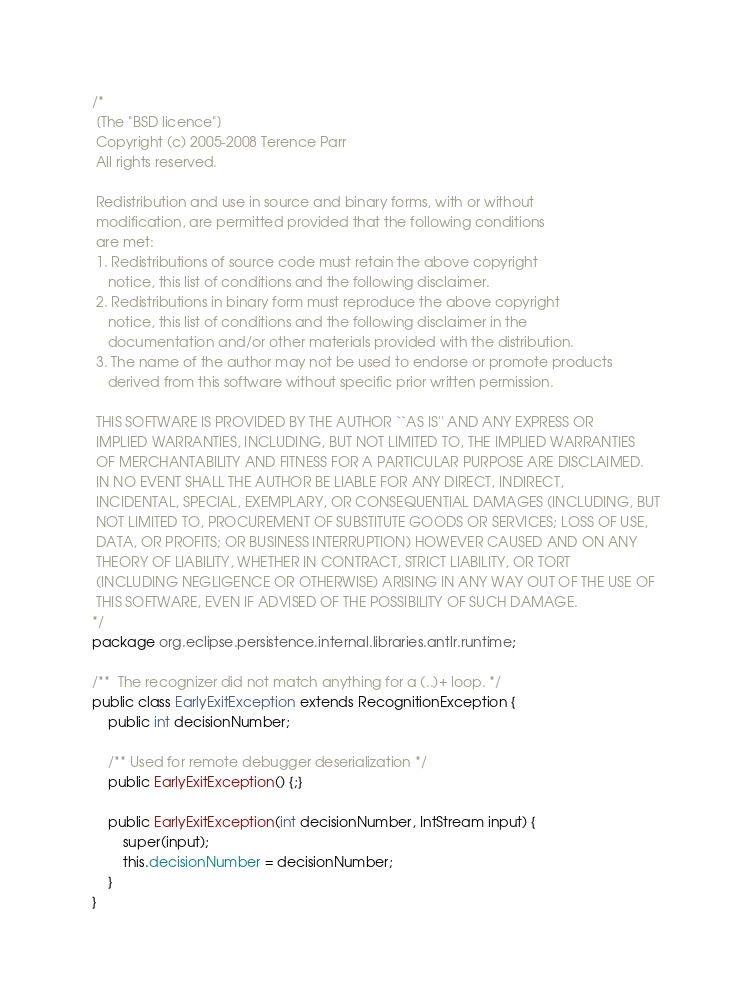Convert code to text. <code><loc_0><loc_0><loc_500><loc_500><_Java_>/*
 [The "BSD licence"]
 Copyright (c) 2005-2008 Terence Parr
 All rights reserved.

 Redistribution and use in source and binary forms, with or without
 modification, are permitted provided that the following conditions
 are met:
 1. Redistributions of source code must retain the above copyright
    notice, this list of conditions and the following disclaimer.
 2. Redistributions in binary form must reproduce the above copyright
    notice, this list of conditions and the following disclaimer in the
    documentation and/or other materials provided with the distribution.
 3. The name of the author may not be used to endorse or promote products
    derived from this software without specific prior written permission.

 THIS SOFTWARE IS PROVIDED BY THE AUTHOR ``AS IS'' AND ANY EXPRESS OR
 IMPLIED WARRANTIES, INCLUDING, BUT NOT LIMITED TO, THE IMPLIED WARRANTIES
 OF MERCHANTABILITY AND FITNESS FOR A PARTICULAR PURPOSE ARE DISCLAIMED.
 IN NO EVENT SHALL THE AUTHOR BE LIABLE FOR ANY DIRECT, INDIRECT,
 INCIDENTAL, SPECIAL, EXEMPLARY, OR CONSEQUENTIAL DAMAGES (INCLUDING, BUT
 NOT LIMITED TO, PROCUREMENT OF SUBSTITUTE GOODS OR SERVICES; LOSS OF USE,
 DATA, OR PROFITS; OR BUSINESS INTERRUPTION) HOWEVER CAUSED AND ON ANY
 THEORY OF LIABILITY, WHETHER IN CONTRACT, STRICT LIABILITY, OR TORT
 (INCLUDING NEGLIGENCE OR OTHERWISE) ARISING IN ANY WAY OUT OF THE USE OF
 THIS SOFTWARE, EVEN IF ADVISED OF THE POSSIBILITY OF SUCH DAMAGE.
*/
package org.eclipse.persistence.internal.libraries.antlr.runtime;

/**  The recognizer did not match anything for a (..)+ loop. */
public class EarlyExitException extends RecognitionException {
	public int decisionNumber;

	/** Used for remote debugger deserialization */
	public EarlyExitException() {;}
	
	public EarlyExitException(int decisionNumber, IntStream input) {
		super(input);
		this.decisionNumber = decisionNumber;
	}
}
</code> 